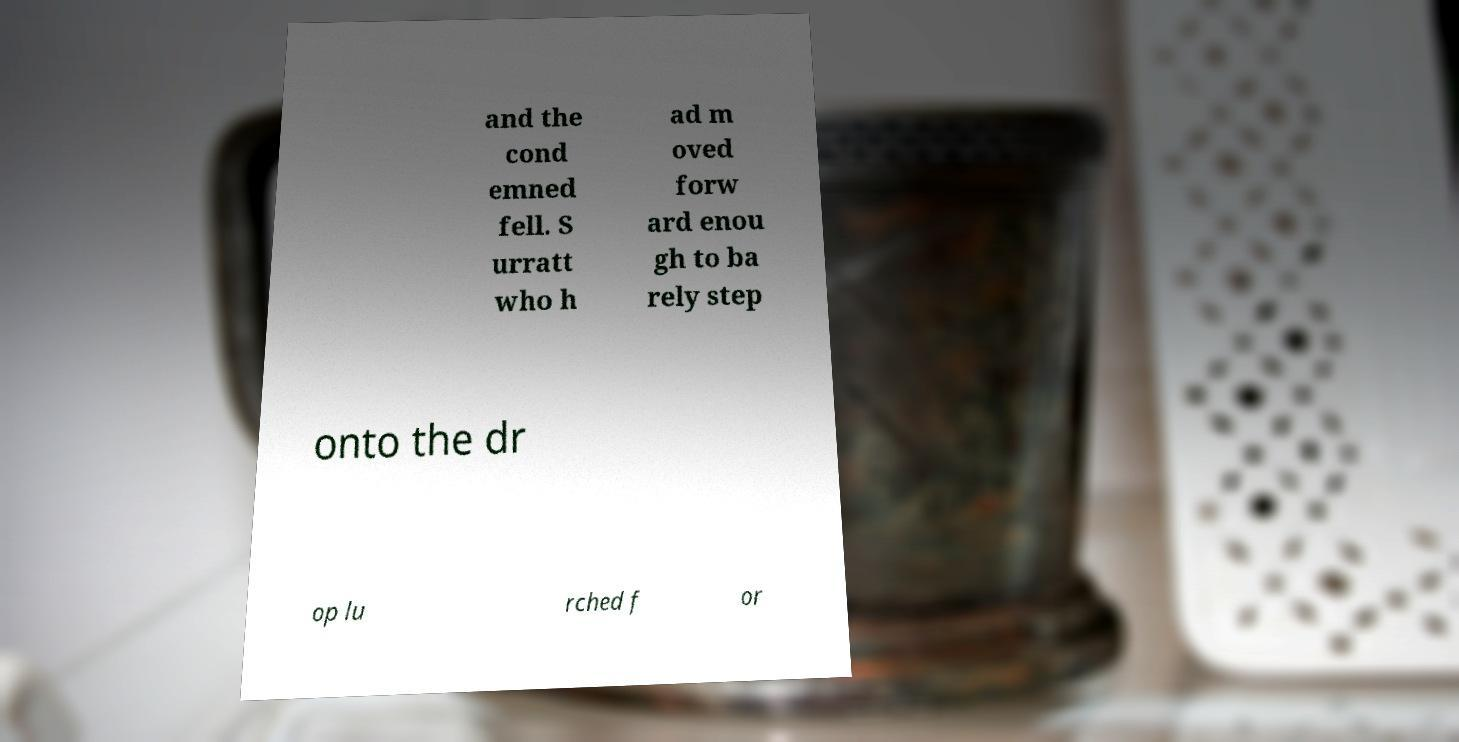Please read and relay the text visible in this image. What does it say? and the cond emned fell. S urratt who h ad m oved forw ard enou gh to ba rely step onto the dr op lu rched f or 